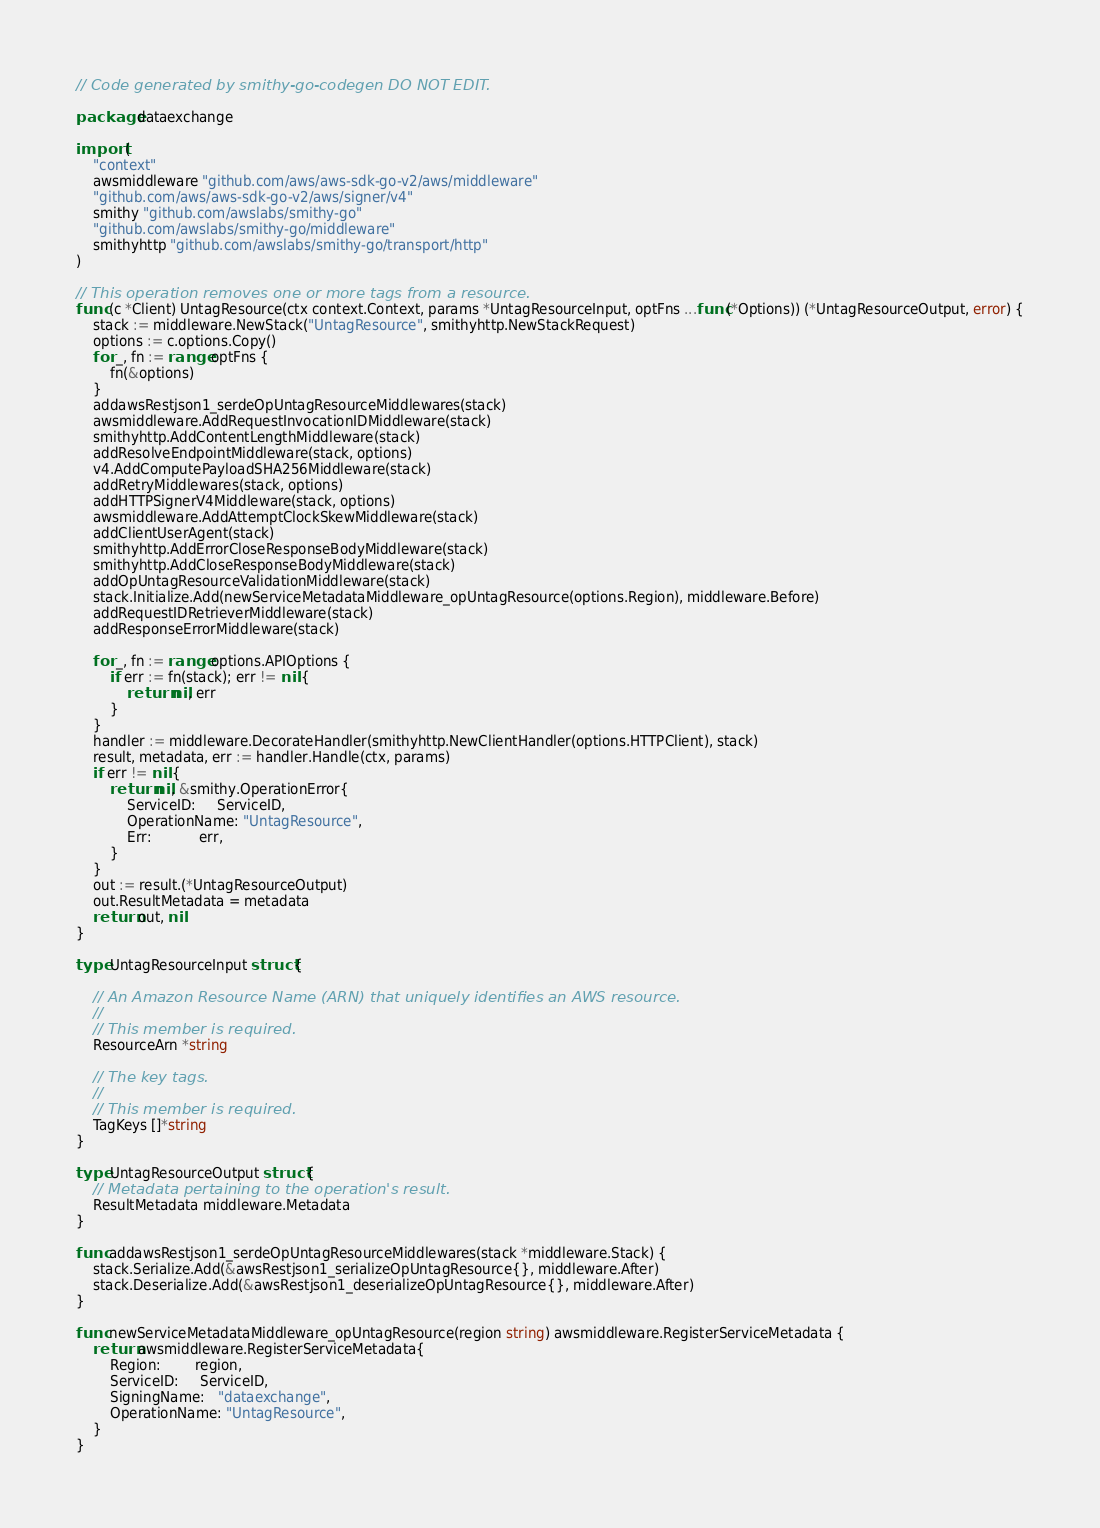<code> <loc_0><loc_0><loc_500><loc_500><_Go_>// Code generated by smithy-go-codegen DO NOT EDIT.

package dataexchange

import (
	"context"
	awsmiddleware "github.com/aws/aws-sdk-go-v2/aws/middleware"
	"github.com/aws/aws-sdk-go-v2/aws/signer/v4"
	smithy "github.com/awslabs/smithy-go"
	"github.com/awslabs/smithy-go/middleware"
	smithyhttp "github.com/awslabs/smithy-go/transport/http"
)

// This operation removes one or more tags from a resource.
func (c *Client) UntagResource(ctx context.Context, params *UntagResourceInput, optFns ...func(*Options)) (*UntagResourceOutput, error) {
	stack := middleware.NewStack("UntagResource", smithyhttp.NewStackRequest)
	options := c.options.Copy()
	for _, fn := range optFns {
		fn(&options)
	}
	addawsRestjson1_serdeOpUntagResourceMiddlewares(stack)
	awsmiddleware.AddRequestInvocationIDMiddleware(stack)
	smithyhttp.AddContentLengthMiddleware(stack)
	addResolveEndpointMiddleware(stack, options)
	v4.AddComputePayloadSHA256Middleware(stack)
	addRetryMiddlewares(stack, options)
	addHTTPSignerV4Middleware(stack, options)
	awsmiddleware.AddAttemptClockSkewMiddleware(stack)
	addClientUserAgent(stack)
	smithyhttp.AddErrorCloseResponseBodyMiddleware(stack)
	smithyhttp.AddCloseResponseBodyMiddleware(stack)
	addOpUntagResourceValidationMiddleware(stack)
	stack.Initialize.Add(newServiceMetadataMiddleware_opUntagResource(options.Region), middleware.Before)
	addRequestIDRetrieverMiddleware(stack)
	addResponseErrorMiddleware(stack)

	for _, fn := range options.APIOptions {
		if err := fn(stack); err != nil {
			return nil, err
		}
	}
	handler := middleware.DecorateHandler(smithyhttp.NewClientHandler(options.HTTPClient), stack)
	result, metadata, err := handler.Handle(ctx, params)
	if err != nil {
		return nil, &smithy.OperationError{
			ServiceID:     ServiceID,
			OperationName: "UntagResource",
			Err:           err,
		}
	}
	out := result.(*UntagResourceOutput)
	out.ResultMetadata = metadata
	return out, nil
}

type UntagResourceInput struct {

	// An Amazon Resource Name (ARN) that uniquely identifies an AWS resource.
	//
	// This member is required.
	ResourceArn *string

	// The key tags.
	//
	// This member is required.
	TagKeys []*string
}

type UntagResourceOutput struct {
	// Metadata pertaining to the operation's result.
	ResultMetadata middleware.Metadata
}

func addawsRestjson1_serdeOpUntagResourceMiddlewares(stack *middleware.Stack) {
	stack.Serialize.Add(&awsRestjson1_serializeOpUntagResource{}, middleware.After)
	stack.Deserialize.Add(&awsRestjson1_deserializeOpUntagResource{}, middleware.After)
}

func newServiceMetadataMiddleware_opUntagResource(region string) awsmiddleware.RegisterServiceMetadata {
	return awsmiddleware.RegisterServiceMetadata{
		Region:        region,
		ServiceID:     ServiceID,
		SigningName:   "dataexchange",
		OperationName: "UntagResource",
	}
}
</code> 